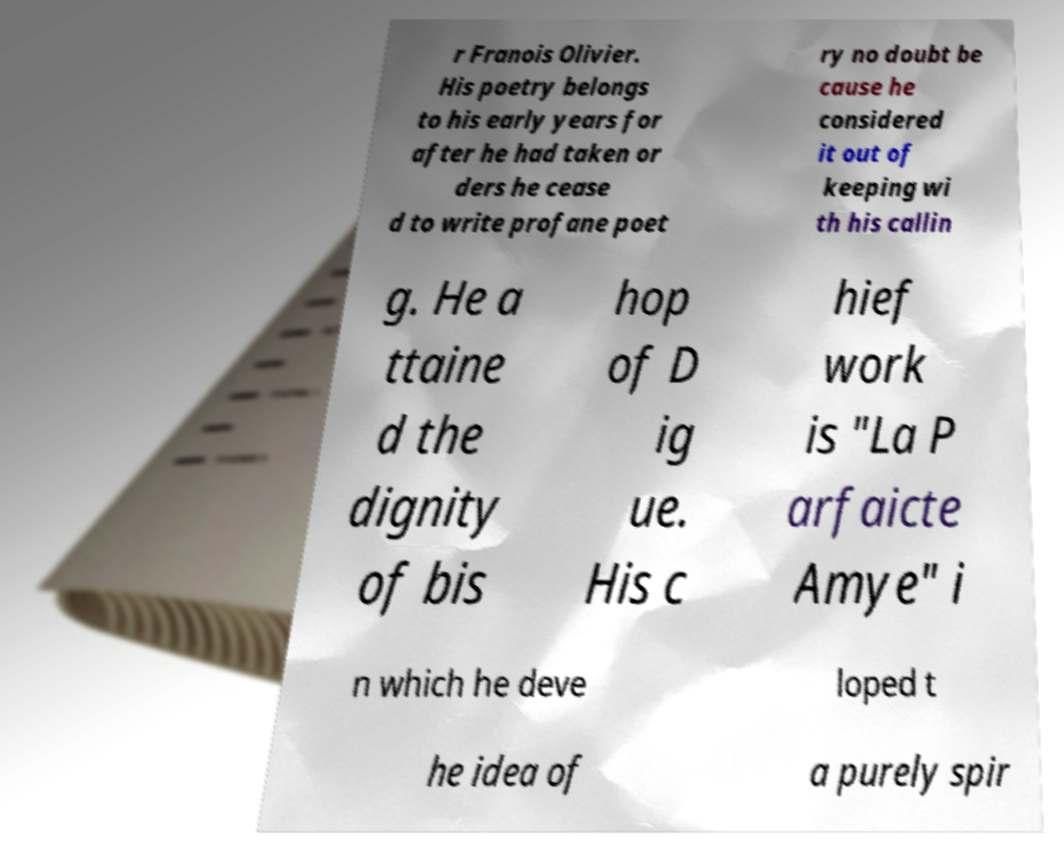Can you accurately transcribe the text from the provided image for me? r Franois Olivier. His poetry belongs to his early years for after he had taken or ders he cease d to write profane poet ry no doubt be cause he considered it out of keeping wi th his callin g. He a ttaine d the dignity of bis hop of D ig ue. His c hief work is "La P arfaicte Amye" i n which he deve loped t he idea of a purely spir 